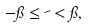Convert formula to latex. <formula><loc_0><loc_0><loc_500><loc_500>- \pi \leq \psi < \pi ,</formula> 